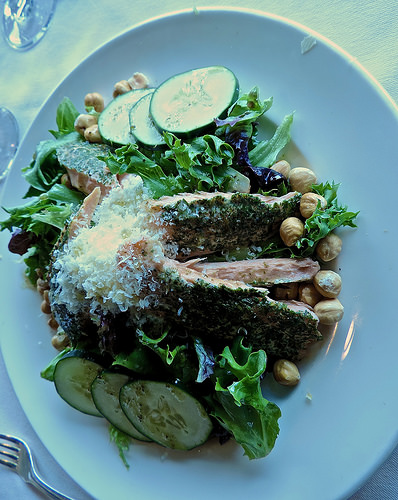<image>
Is there a cheese on the cucumber? No. The cheese is not positioned on the cucumber. They may be near each other, but the cheese is not supported by or resting on top of the cucumber. 